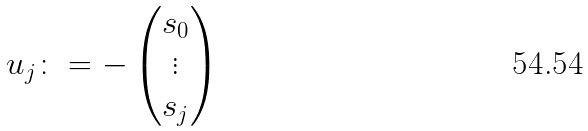Convert formula to latex. <formula><loc_0><loc_0><loc_500><loc_500>u _ { j } \colon = - \begin{pmatrix} s _ { 0 } \\ \vdots \\ s _ { j } \end{pmatrix}</formula> 